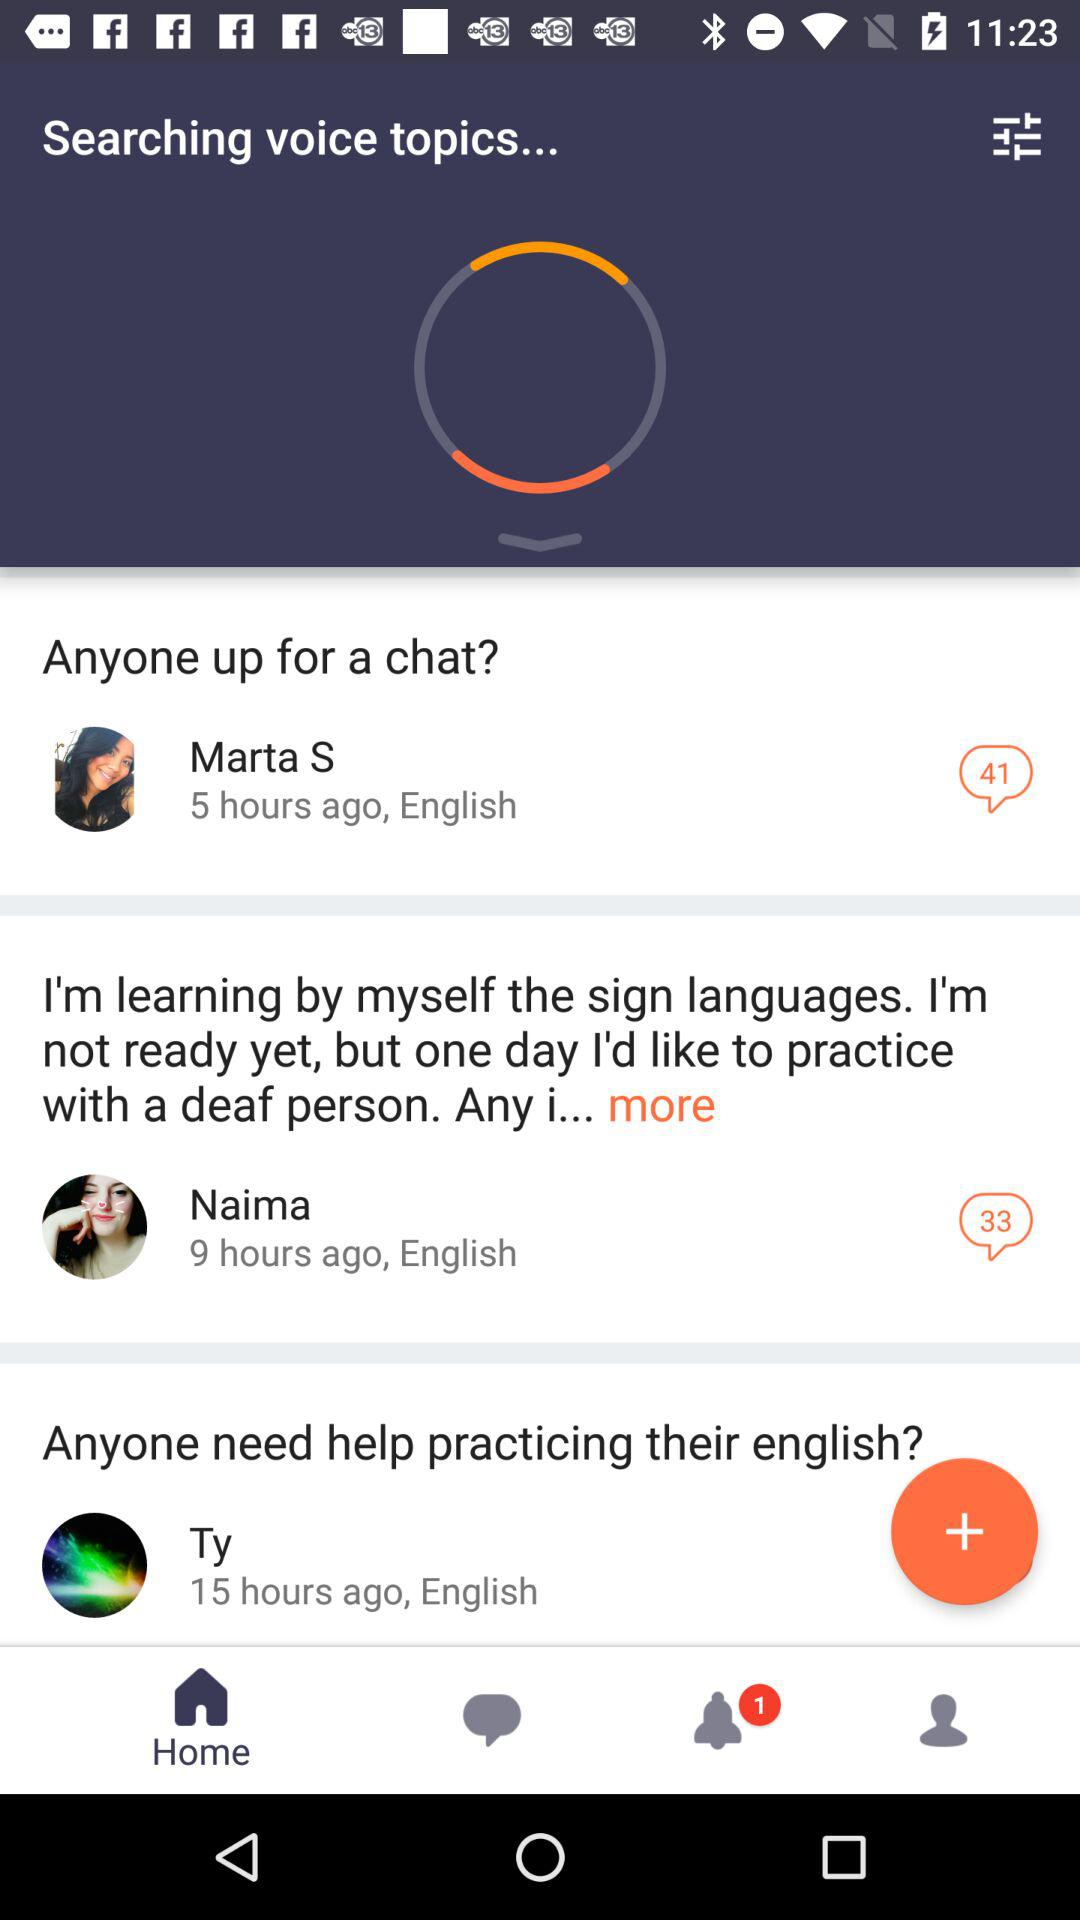Which language is used by Naima? The language used by Naima is English. 